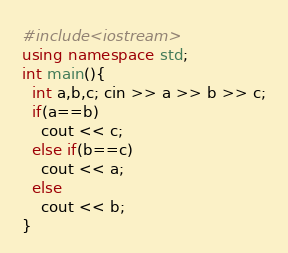Convert code to text. <code><loc_0><loc_0><loc_500><loc_500><_C++_>#include<iostream>
using namespace std;
int main(){
  int a,b,c; cin >> a >> b >> c;
  if(a==b)
    cout << c;
  else if(b==c)
    cout << a;
  else
    cout << b;
}</code> 